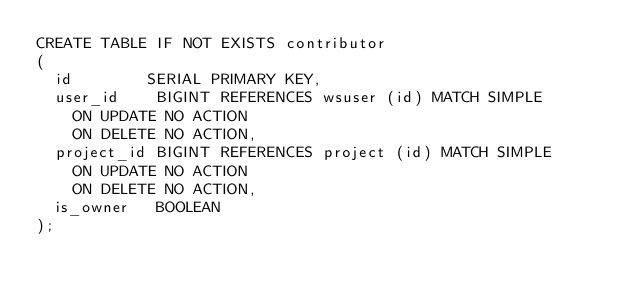Convert code to text. <code><loc_0><loc_0><loc_500><loc_500><_SQL_>CREATE TABLE IF NOT EXISTS contributor
(
  id        SERIAL PRIMARY KEY,
  user_id    BIGINT REFERENCES wsuser (id) MATCH SIMPLE
    ON UPDATE NO ACTION
    ON DELETE NO ACTION,
  project_id BIGINT REFERENCES project (id) MATCH SIMPLE
    ON UPDATE NO ACTION
    ON DELETE NO ACTION,
  is_owner   BOOLEAN
);
</code> 